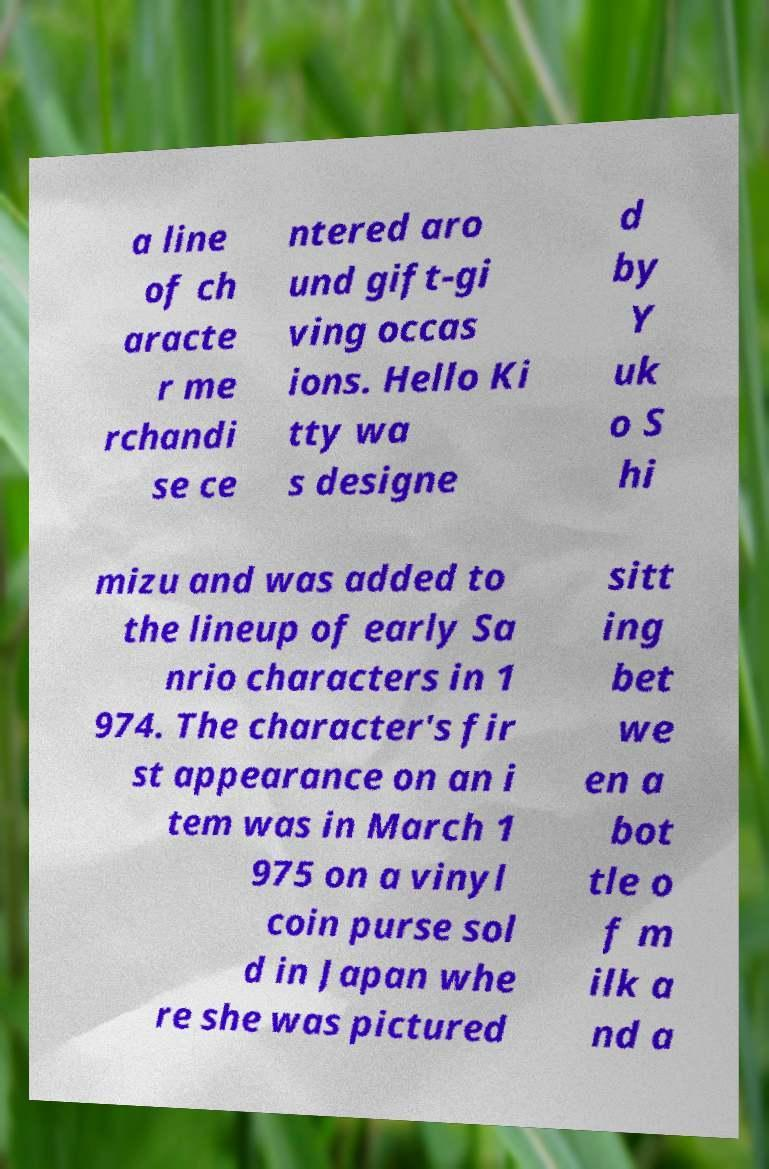Can you accurately transcribe the text from the provided image for me? a line of ch aracte r me rchandi se ce ntered aro und gift-gi ving occas ions. Hello Ki tty wa s designe d by Y uk o S hi mizu and was added to the lineup of early Sa nrio characters in 1 974. The character's fir st appearance on an i tem was in March 1 975 on a vinyl coin purse sol d in Japan whe re she was pictured sitt ing bet we en a bot tle o f m ilk a nd a 